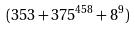Convert formula to latex. <formula><loc_0><loc_0><loc_500><loc_500>( 3 5 3 + 3 7 5 ^ { 4 5 8 } + 8 ^ { 9 } )</formula> 